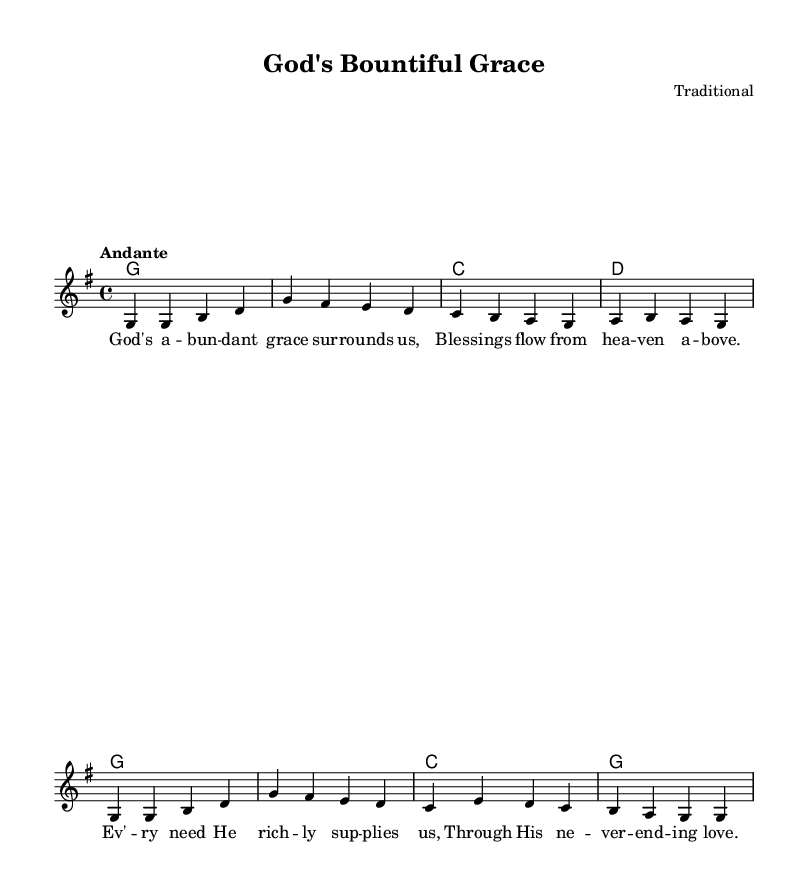What is the key signature of this music? The key signature is G major, which has one sharp (F#). This can be determined from the key signature indicated at the beginning of the piece.
Answer: G major What is the time signature of this music? The time signature is four-four, indicated by the notation at the beginning of the score (4/4), meaning there are four beats in each measure.
Answer: Four-four What is the tempo marking for this piece? The tempo marking is Andante, suggesting a moderate pace. This marking is shown at the beginning of the score, dictating the speed of the performance.
Answer: Andante How many measures are there in the melody? There are eight measures in the melody. You can count the vertical lines separating each measure in the staff to find the number of measures.
Answer: Eight What is the first line of lyrics in this hymn? The first line of lyrics is "God's abundant grace surrounds us." This line corresponds to the first group of notes in the melody and is placed directly below those notes in the lyrics section.
Answer: God's abundant grace surrounds us What chord is played in the first measure? The chord played in the first measure is G major. This is derived from the chord indicated in the chord section next to the melody line, where "g1" signifies a G major chord.
Answer: G major Why is this hymn focused on themes of abundance and provision? This hymn focuses on themes of abundance and provision as reflected in its lyrics, emphasizing blessings and God's continual support. The content and structure of the lyrics align with religious themes of reliance on divine providence, showcasing gratitude for those blessings.
Answer: Gratitude for divine blessings 